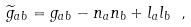Convert formula to latex. <formula><loc_0><loc_0><loc_500><loc_500>\widetilde { g } _ { a b } = g _ { a b } - n _ { a } n _ { b } + l _ { a } l _ { b } \ ,</formula> 